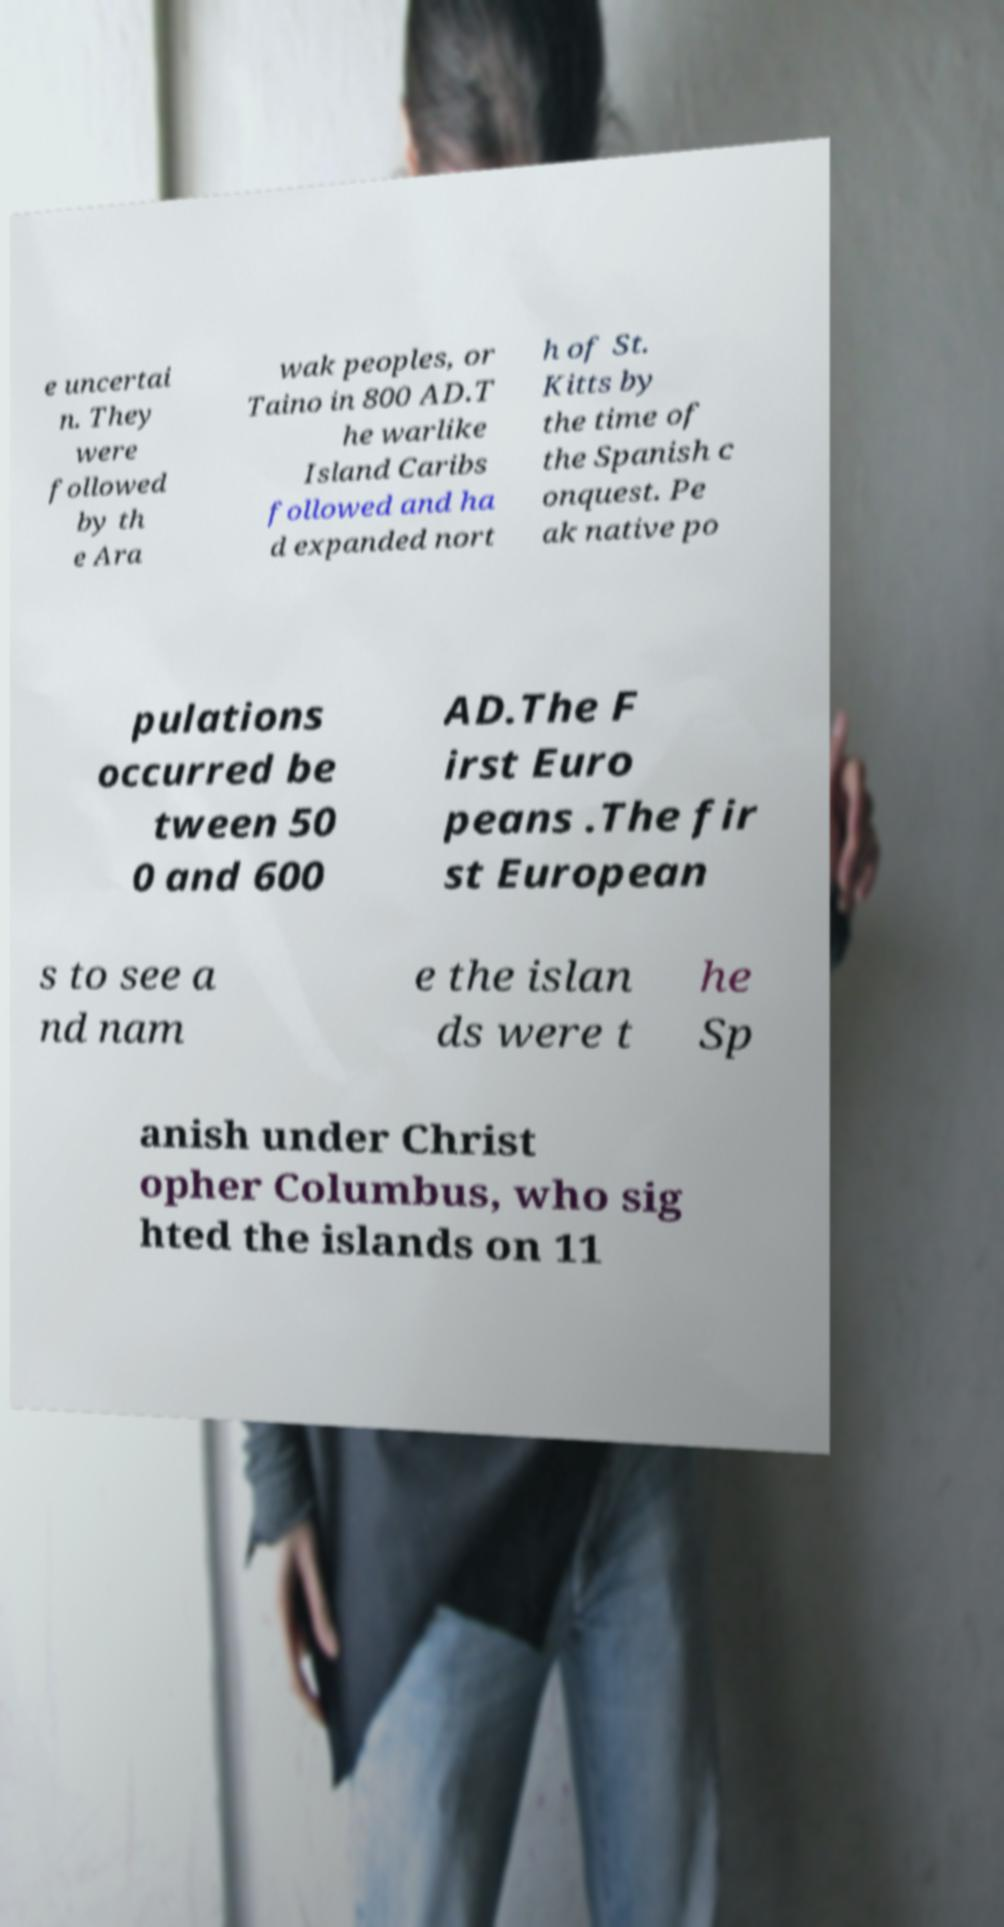What messages or text are displayed in this image? I need them in a readable, typed format. e uncertai n. They were followed by th e Ara wak peoples, or Taino in 800 AD.T he warlike Island Caribs followed and ha d expanded nort h of St. Kitts by the time of the Spanish c onquest. Pe ak native po pulations occurred be tween 50 0 and 600 AD.The F irst Euro peans .The fir st European s to see a nd nam e the islan ds were t he Sp anish under Christ opher Columbus, who sig hted the islands on 11 